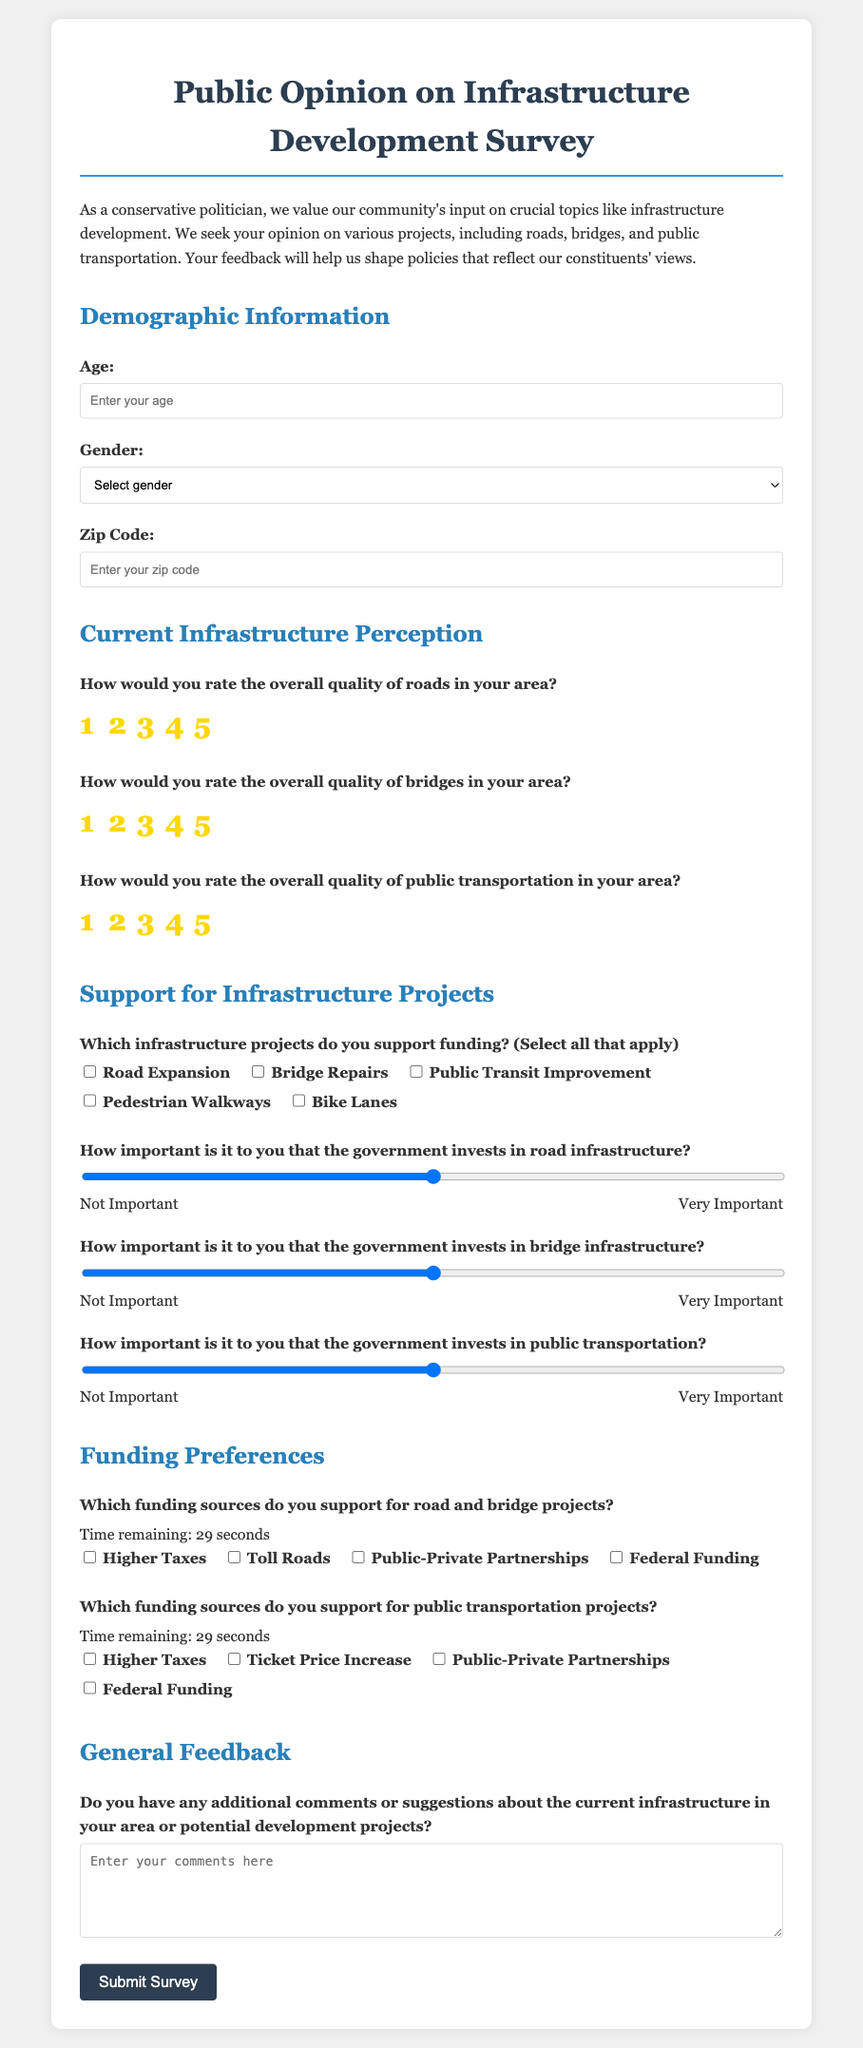What is the title of the survey? The title of the survey is provided at the top of the document and is "Public Opinion on Infrastructure Development Survey."
Answer: Public Opinion on Infrastructure Development Survey How many sections are in the survey? The survey consists of three main sections: Demographic Information, Current Infrastructure Perception, Support for Infrastructure Projects, and Funding Preferences.
Answer: Four What is the maximum rating scale for the quality of roads? The maximum rating scale for the quality of roads is indicated with radio buttons labeled from 1 to 5, with 5 being the highest rating.
Answer: 5 What type of projects can respondents support funding? The document lists multiple options for respondents to select from, which includes "Road Expansion," "Bridge Repairs," "Public Transit Improvement," "Pedestrian Walkways," and "Bike Lanes."
Answer: Road Expansion, Bridge Repairs, Public Transit Improvement, Pedestrian Walkways, Bike Lanes How important is government investment in road infrastructure? Respondents can indicate the level of importance by selecting a value on a scale from 1 to 5, where 1 is "Not Important" and 5 is "Very Important."
Answer: 1 to 5 What additional comment section is available at the end of the survey? The survey includes a text area where respondents can provide their comments or suggestions about current infrastructure or potential development projects.
Answer: Additional comments or suggestions Is there a time limit for responding to the funding sources questions? Yes, the survey includes a timer indicating that the respondents have a limited time of 30 seconds to fill out the funding sources questions.
Answer: 30 seconds Which funding source is listed for road and bridge projects? The survey presents options for funding sources, one of which includes "Public-Private Partnerships."
Answer: Public-Private Partnerships How does the survey request participant's age? The survey includes an input field labeled "Age," encouraging participants to enter their age directly.
Answer: Enter your age 